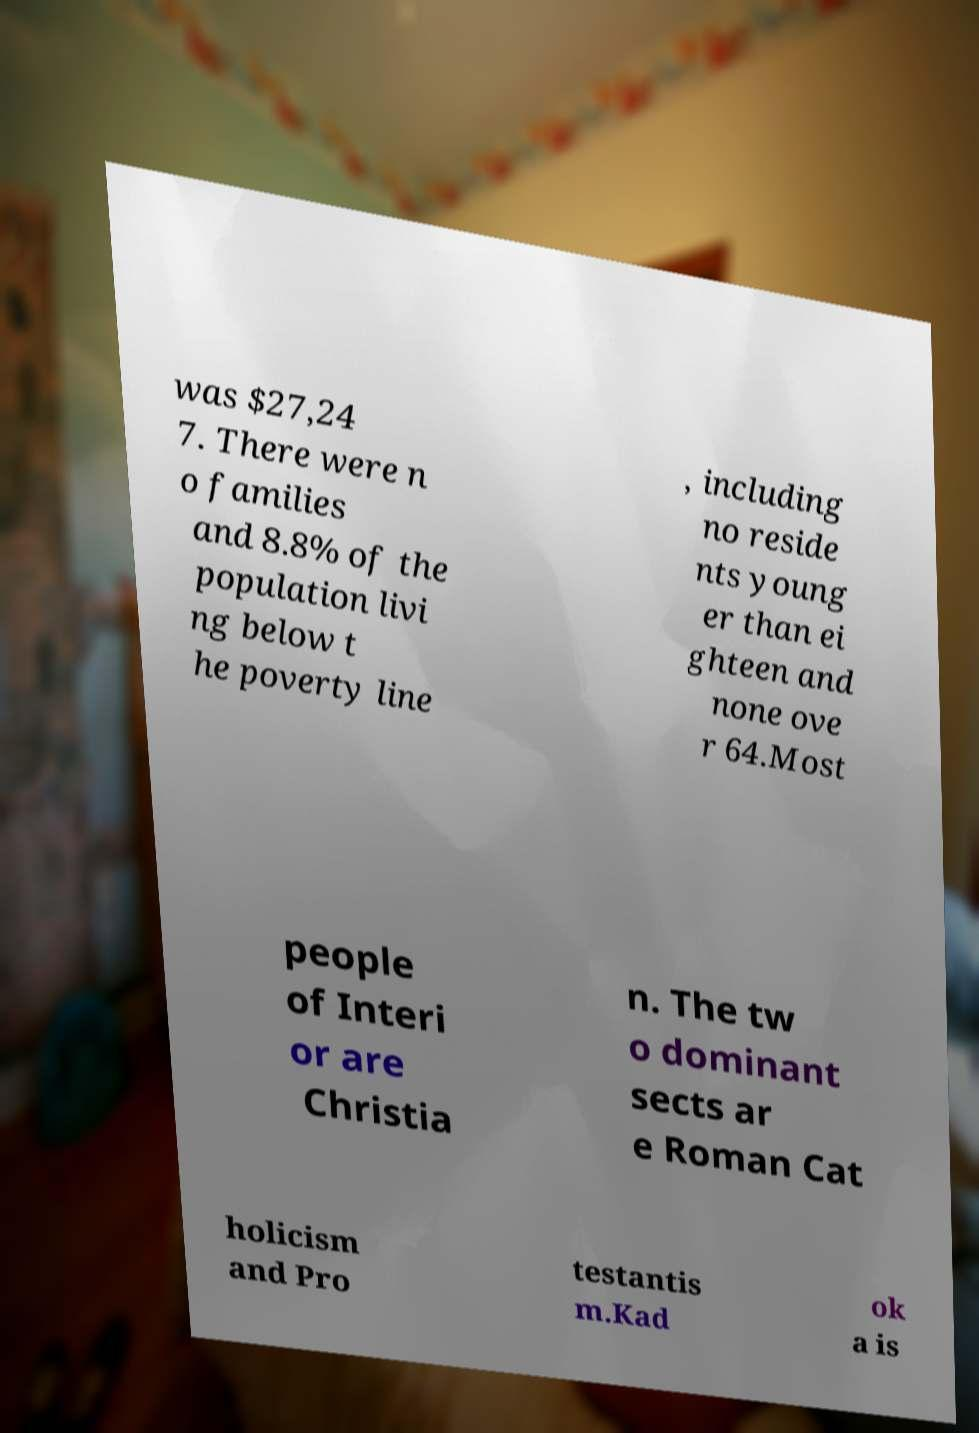For documentation purposes, I need the text within this image transcribed. Could you provide that? was $27,24 7. There were n o families and 8.8% of the population livi ng below t he poverty line , including no reside nts young er than ei ghteen and none ove r 64.Most people of Interi or are Christia n. The tw o dominant sects ar e Roman Cat holicism and Pro testantis m.Kad ok a is 